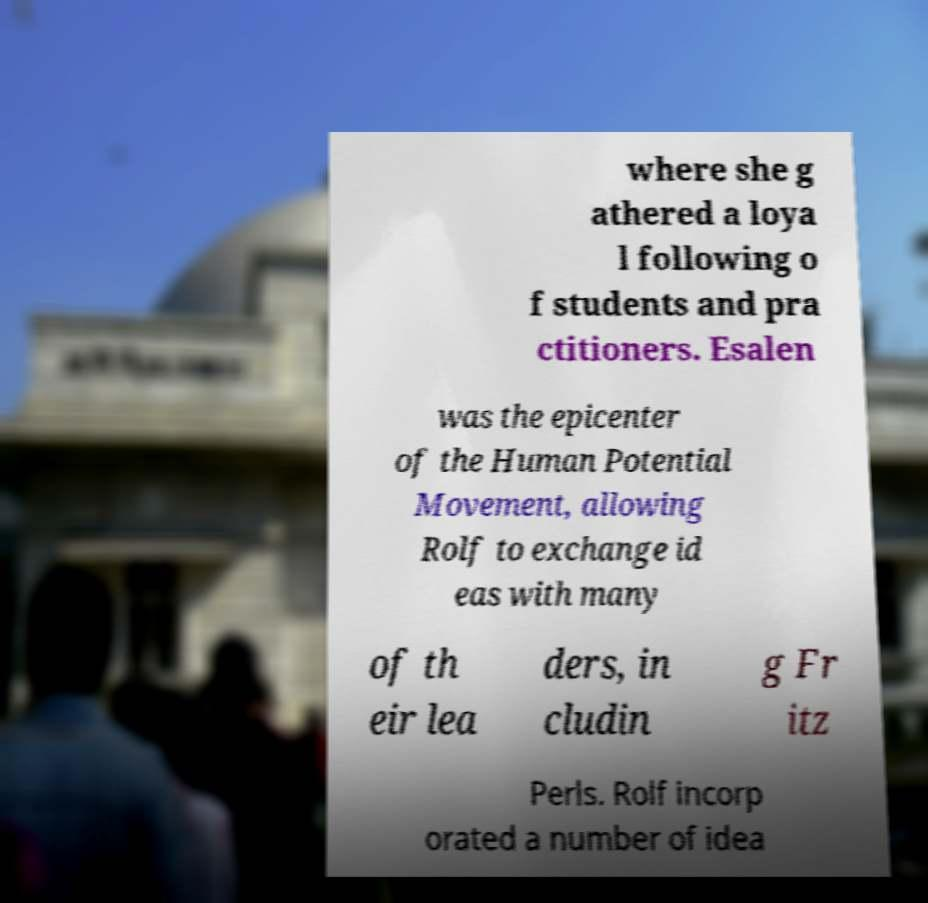Can you read and provide the text displayed in the image?This photo seems to have some interesting text. Can you extract and type it out for me? where she g athered a loya l following o f students and pra ctitioners. Esalen was the epicenter of the Human Potential Movement, allowing Rolf to exchange id eas with many of th eir lea ders, in cludin g Fr itz Perls. Rolf incorp orated a number of idea 